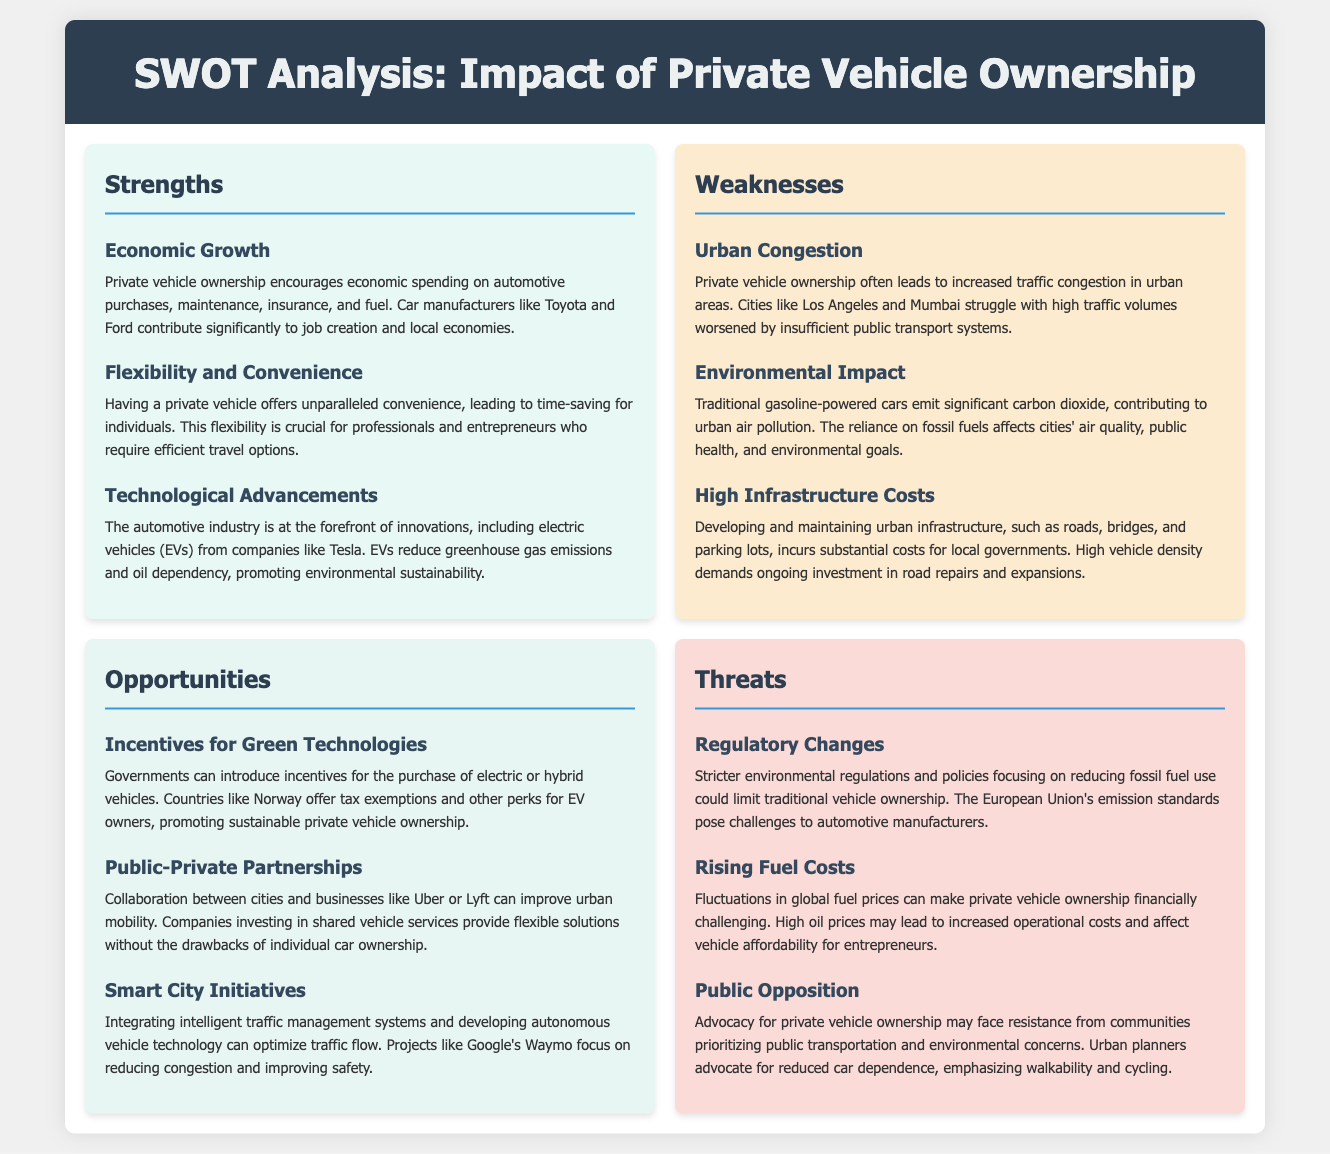What is one economic benefit of private vehicle ownership? The document states that private vehicle ownership encourages economic spending on automotive purchases, maintenance, insurance, and fuel.
Answer: Economic Growth What environmental concern is associated with traditional gasoline-powered cars? The document highlights that traditional gasoline-powered cars emit significant carbon dioxide, contributing to urban air pollution.
Answer: Environmental Impact Which country is mentioned as providing incentives for electric vehicle owners? The document references Norway as a country that offers tax exemptions and perks for EV owners.
Answer: Norway What type of technology development is associated with smart city initiatives? The document mentions integrating intelligent traffic management systems and developing autonomous vehicle technology.
Answer: Intelligent traffic management systems What threat could impact traditional vehicle ownership? The document lists stricter environmental regulations and policies focusing on reducing fossil fuel use as a threat.
Answer: Regulatory Changes What is a consequence of high vehicle density according to the weaknesses section? The document states that high vehicle density demands ongoing investment in road repairs and expansions.
Answer: High Infrastructure Costs Which automotive company is mentioned in relation to technological advancements? The document mentions Tesla in connection with innovations such as electric vehicles.
Answer: Tesla What type of partnerships can improve urban mobility? The document suggests that public-private partnerships between cities and companies like Uber or Lyft can improve urban mobility.
Answer: Public-Private Partnerships 